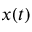Convert formula to latex. <formula><loc_0><loc_0><loc_500><loc_500>x ( t )</formula> 